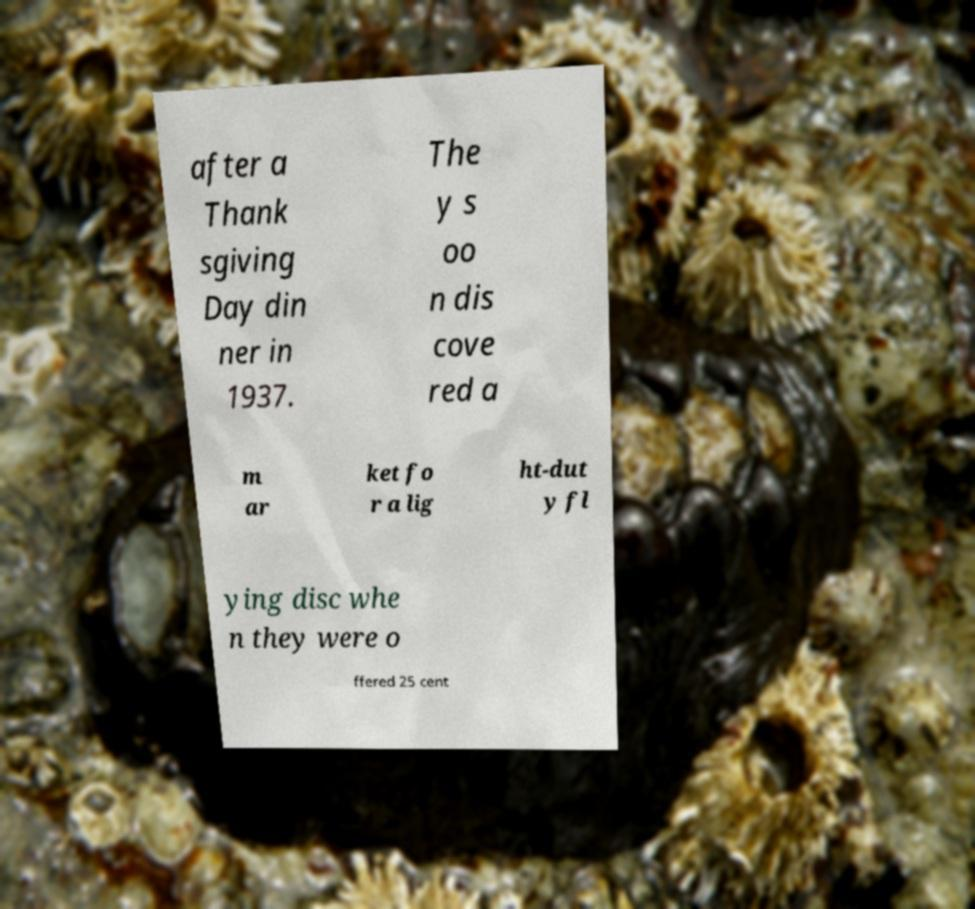Could you assist in decoding the text presented in this image and type it out clearly? after a Thank sgiving Day din ner in 1937. The y s oo n dis cove red a m ar ket fo r a lig ht-dut y fl ying disc whe n they were o ffered 25 cent 